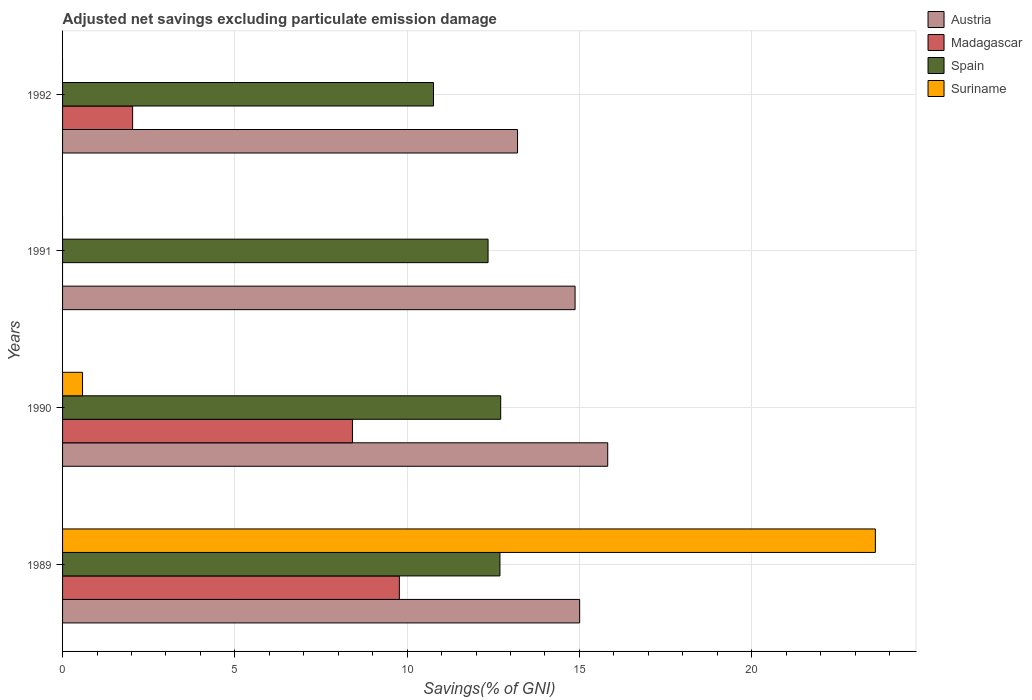How many different coloured bars are there?
Give a very brief answer. 4. How many groups of bars are there?
Provide a short and direct response. 4. Are the number of bars per tick equal to the number of legend labels?
Give a very brief answer. No. What is the label of the 1st group of bars from the top?
Give a very brief answer. 1992. In how many cases, is the number of bars for a given year not equal to the number of legend labels?
Make the answer very short. 2. What is the adjusted net savings in Austria in 1989?
Provide a short and direct response. 15.01. Across all years, what is the maximum adjusted net savings in Austria?
Give a very brief answer. 15.82. Across all years, what is the minimum adjusted net savings in Austria?
Your answer should be very brief. 13.2. What is the total adjusted net savings in Spain in the graph?
Give a very brief answer. 48.52. What is the difference between the adjusted net savings in Spain in 1989 and that in 1991?
Offer a very short reply. 0.34. What is the difference between the adjusted net savings in Suriname in 1990 and the adjusted net savings in Austria in 1992?
Provide a succinct answer. -12.63. What is the average adjusted net savings in Madagascar per year?
Give a very brief answer. 5.06. In the year 1989, what is the difference between the adjusted net savings in Suriname and adjusted net savings in Austria?
Provide a short and direct response. 8.58. In how many years, is the adjusted net savings in Suriname greater than 7 %?
Your response must be concise. 1. What is the ratio of the adjusted net savings in Austria in 1990 to that in 1992?
Provide a short and direct response. 1.2. Is the difference between the adjusted net savings in Suriname in 1989 and 1990 greater than the difference between the adjusted net savings in Austria in 1989 and 1990?
Keep it short and to the point. Yes. What is the difference between the highest and the second highest adjusted net savings in Austria?
Provide a succinct answer. 0.81. What is the difference between the highest and the lowest adjusted net savings in Suriname?
Your answer should be compact. 23.59. In how many years, is the adjusted net savings in Madagascar greater than the average adjusted net savings in Madagascar taken over all years?
Provide a short and direct response. 2. Is it the case that in every year, the sum of the adjusted net savings in Austria and adjusted net savings in Madagascar is greater than the sum of adjusted net savings in Suriname and adjusted net savings in Spain?
Your response must be concise. No. Is it the case that in every year, the sum of the adjusted net savings in Spain and adjusted net savings in Austria is greater than the adjusted net savings in Madagascar?
Your response must be concise. Yes. How many bars are there?
Provide a succinct answer. 13. What is the difference between two consecutive major ticks on the X-axis?
Your response must be concise. 5. Are the values on the major ticks of X-axis written in scientific E-notation?
Provide a short and direct response. No. Does the graph contain any zero values?
Offer a very short reply. Yes. Does the graph contain grids?
Make the answer very short. Yes. How many legend labels are there?
Provide a short and direct response. 4. How are the legend labels stacked?
Keep it short and to the point. Vertical. What is the title of the graph?
Your answer should be compact. Adjusted net savings excluding particulate emission damage. What is the label or title of the X-axis?
Your answer should be very brief. Savings(% of GNI). What is the Savings(% of GNI) of Austria in 1989?
Ensure brevity in your answer.  15.01. What is the Savings(% of GNI) in Madagascar in 1989?
Keep it short and to the point. 9.77. What is the Savings(% of GNI) in Spain in 1989?
Make the answer very short. 12.69. What is the Savings(% of GNI) of Suriname in 1989?
Your response must be concise. 23.59. What is the Savings(% of GNI) of Austria in 1990?
Give a very brief answer. 15.82. What is the Savings(% of GNI) of Madagascar in 1990?
Keep it short and to the point. 8.41. What is the Savings(% of GNI) in Spain in 1990?
Your answer should be very brief. 12.72. What is the Savings(% of GNI) in Suriname in 1990?
Your answer should be compact. 0.58. What is the Savings(% of GNI) in Austria in 1991?
Provide a short and direct response. 14.87. What is the Savings(% of GNI) in Madagascar in 1991?
Your answer should be very brief. 0. What is the Savings(% of GNI) of Spain in 1991?
Offer a very short reply. 12.35. What is the Savings(% of GNI) in Austria in 1992?
Make the answer very short. 13.2. What is the Savings(% of GNI) in Madagascar in 1992?
Your answer should be very brief. 2.03. What is the Savings(% of GNI) in Spain in 1992?
Ensure brevity in your answer.  10.77. What is the Savings(% of GNI) of Suriname in 1992?
Ensure brevity in your answer.  0. Across all years, what is the maximum Savings(% of GNI) of Austria?
Offer a terse response. 15.82. Across all years, what is the maximum Savings(% of GNI) of Madagascar?
Make the answer very short. 9.77. Across all years, what is the maximum Savings(% of GNI) of Spain?
Make the answer very short. 12.72. Across all years, what is the maximum Savings(% of GNI) of Suriname?
Offer a terse response. 23.59. Across all years, what is the minimum Savings(% of GNI) of Austria?
Give a very brief answer. 13.2. Across all years, what is the minimum Savings(% of GNI) of Spain?
Offer a very short reply. 10.77. Across all years, what is the minimum Savings(% of GNI) of Suriname?
Your answer should be very brief. 0. What is the total Savings(% of GNI) of Austria in the graph?
Give a very brief answer. 58.91. What is the total Savings(% of GNI) of Madagascar in the graph?
Keep it short and to the point. 20.22. What is the total Savings(% of GNI) in Spain in the graph?
Provide a short and direct response. 48.52. What is the total Savings(% of GNI) of Suriname in the graph?
Provide a short and direct response. 24.17. What is the difference between the Savings(% of GNI) of Austria in 1989 and that in 1990?
Offer a terse response. -0.81. What is the difference between the Savings(% of GNI) in Madagascar in 1989 and that in 1990?
Make the answer very short. 1.36. What is the difference between the Savings(% of GNI) in Spain in 1989 and that in 1990?
Your response must be concise. -0.02. What is the difference between the Savings(% of GNI) of Suriname in 1989 and that in 1990?
Provide a succinct answer. 23.01. What is the difference between the Savings(% of GNI) of Austria in 1989 and that in 1991?
Keep it short and to the point. 0.13. What is the difference between the Savings(% of GNI) of Spain in 1989 and that in 1991?
Your response must be concise. 0.34. What is the difference between the Savings(% of GNI) in Austria in 1989 and that in 1992?
Ensure brevity in your answer.  1.8. What is the difference between the Savings(% of GNI) of Madagascar in 1989 and that in 1992?
Provide a succinct answer. 7.74. What is the difference between the Savings(% of GNI) in Spain in 1989 and that in 1992?
Make the answer very short. 1.93. What is the difference between the Savings(% of GNI) in Austria in 1990 and that in 1991?
Give a very brief answer. 0.95. What is the difference between the Savings(% of GNI) in Spain in 1990 and that in 1991?
Keep it short and to the point. 0.37. What is the difference between the Savings(% of GNI) in Austria in 1990 and that in 1992?
Provide a short and direct response. 2.62. What is the difference between the Savings(% of GNI) in Madagascar in 1990 and that in 1992?
Make the answer very short. 6.38. What is the difference between the Savings(% of GNI) of Spain in 1990 and that in 1992?
Your response must be concise. 1.95. What is the difference between the Savings(% of GNI) of Austria in 1991 and that in 1992?
Ensure brevity in your answer.  1.67. What is the difference between the Savings(% of GNI) of Spain in 1991 and that in 1992?
Ensure brevity in your answer.  1.58. What is the difference between the Savings(% of GNI) of Austria in 1989 and the Savings(% of GNI) of Madagascar in 1990?
Ensure brevity in your answer.  6.59. What is the difference between the Savings(% of GNI) in Austria in 1989 and the Savings(% of GNI) in Spain in 1990?
Offer a very short reply. 2.29. What is the difference between the Savings(% of GNI) in Austria in 1989 and the Savings(% of GNI) in Suriname in 1990?
Your response must be concise. 14.43. What is the difference between the Savings(% of GNI) of Madagascar in 1989 and the Savings(% of GNI) of Spain in 1990?
Offer a very short reply. -2.94. What is the difference between the Savings(% of GNI) of Madagascar in 1989 and the Savings(% of GNI) of Suriname in 1990?
Keep it short and to the point. 9.19. What is the difference between the Savings(% of GNI) of Spain in 1989 and the Savings(% of GNI) of Suriname in 1990?
Ensure brevity in your answer.  12.11. What is the difference between the Savings(% of GNI) in Austria in 1989 and the Savings(% of GNI) in Spain in 1991?
Your answer should be compact. 2.66. What is the difference between the Savings(% of GNI) of Madagascar in 1989 and the Savings(% of GNI) of Spain in 1991?
Give a very brief answer. -2.57. What is the difference between the Savings(% of GNI) in Austria in 1989 and the Savings(% of GNI) in Madagascar in 1992?
Offer a terse response. 12.97. What is the difference between the Savings(% of GNI) of Austria in 1989 and the Savings(% of GNI) of Spain in 1992?
Your answer should be very brief. 4.24. What is the difference between the Savings(% of GNI) in Madagascar in 1989 and the Savings(% of GNI) in Spain in 1992?
Your answer should be compact. -0.99. What is the difference between the Savings(% of GNI) of Austria in 1990 and the Savings(% of GNI) of Spain in 1991?
Offer a terse response. 3.47. What is the difference between the Savings(% of GNI) of Madagascar in 1990 and the Savings(% of GNI) of Spain in 1991?
Make the answer very short. -3.94. What is the difference between the Savings(% of GNI) of Austria in 1990 and the Savings(% of GNI) of Madagascar in 1992?
Provide a short and direct response. 13.79. What is the difference between the Savings(% of GNI) in Austria in 1990 and the Savings(% of GNI) in Spain in 1992?
Provide a succinct answer. 5.06. What is the difference between the Savings(% of GNI) of Madagascar in 1990 and the Savings(% of GNI) of Spain in 1992?
Offer a terse response. -2.35. What is the difference between the Savings(% of GNI) of Austria in 1991 and the Savings(% of GNI) of Madagascar in 1992?
Your response must be concise. 12.84. What is the difference between the Savings(% of GNI) of Austria in 1991 and the Savings(% of GNI) of Spain in 1992?
Your answer should be very brief. 4.11. What is the average Savings(% of GNI) of Austria per year?
Provide a succinct answer. 14.73. What is the average Savings(% of GNI) in Madagascar per year?
Offer a terse response. 5.06. What is the average Savings(% of GNI) of Spain per year?
Offer a very short reply. 12.13. What is the average Savings(% of GNI) in Suriname per year?
Offer a terse response. 6.04. In the year 1989, what is the difference between the Savings(% of GNI) in Austria and Savings(% of GNI) in Madagascar?
Keep it short and to the point. 5.23. In the year 1989, what is the difference between the Savings(% of GNI) of Austria and Savings(% of GNI) of Spain?
Your answer should be compact. 2.31. In the year 1989, what is the difference between the Savings(% of GNI) in Austria and Savings(% of GNI) in Suriname?
Offer a terse response. -8.58. In the year 1989, what is the difference between the Savings(% of GNI) in Madagascar and Savings(% of GNI) in Spain?
Offer a very short reply. -2.92. In the year 1989, what is the difference between the Savings(% of GNI) of Madagascar and Savings(% of GNI) of Suriname?
Provide a succinct answer. -13.82. In the year 1989, what is the difference between the Savings(% of GNI) of Spain and Savings(% of GNI) of Suriname?
Make the answer very short. -10.9. In the year 1990, what is the difference between the Savings(% of GNI) in Austria and Savings(% of GNI) in Madagascar?
Offer a terse response. 7.41. In the year 1990, what is the difference between the Savings(% of GNI) in Austria and Savings(% of GNI) in Spain?
Your response must be concise. 3.11. In the year 1990, what is the difference between the Savings(% of GNI) of Austria and Savings(% of GNI) of Suriname?
Your answer should be compact. 15.24. In the year 1990, what is the difference between the Savings(% of GNI) of Madagascar and Savings(% of GNI) of Spain?
Give a very brief answer. -4.3. In the year 1990, what is the difference between the Savings(% of GNI) of Madagascar and Savings(% of GNI) of Suriname?
Your response must be concise. 7.83. In the year 1990, what is the difference between the Savings(% of GNI) of Spain and Savings(% of GNI) of Suriname?
Provide a short and direct response. 12.14. In the year 1991, what is the difference between the Savings(% of GNI) of Austria and Savings(% of GNI) of Spain?
Provide a succinct answer. 2.53. In the year 1992, what is the difference between the Savings(% of GNI) in Austria and Savings(% of GNI) in Madagascar?
Offer a terse response. 11.17. In the year 1992, what is the difference between the Savings(% of GNI) of Austria and Savings(% of GNI) of Spain?
Make the answer very short. 2.44. In the year 1992, what is the difference between the Savings(% of GNI) in Madagascar and Savings(% of GNI) in Spain?
Keep it short and to the point. -8.73. What is the ratio of the Savings(% of GNI) in Austria in 1989 to that in 1990?
Your answer should be very brief. 0.95. What is the ratio of the Savings(% of GNI) of Madagascar in 1989 to that in 1990?
Give a very brief answer. 1.16. What is the ratio of the Savings(% of GNI) of Suriname in 1989 to that in 1990?
Offer a very short reply. 40.71. What is the ratio of the Savings(% of GNI) of Austria in 1989 to that in 1991?
Offer a very short reply. 1.01. What is the ratio of the Savings(% of GNI) in Spain in 1989 to that in 1991?
Offer a terse response. 1.03. What is the ratio of the Savings(% of GNI) of Austria in 1989 to that in 1992?
Offer a very short reply. 1.14. What is the ratio of the Savings(% of GNI) in Madagascar in 1989 to that in 1992?
Your answer should be very brief. 4.81. What is the ratio of the Savings(% of GNI) in Spain in 1989 to that in 1992?
Give a very brief answer. 1.18. What is the ratio of the Savings(% of GNI) in Austria in 1990 to that in 1991?
Ensure brevity in your answer.  1.06. What is the ratio of the Savings(% of GNI) of Spain in 1990 to that in 1991?
Provide a succinct answer. 1.03. What is the ratio of the Savings(% of GNI) of Austria in 1990 to that in 1992?
Provide a short and direct response. 1.2. What is the ratio of the Savings(% of GNI) in Madagascar in 1990 to that in 1992?
Offer a terse response. 4.14. What is the ratio of the Savings(% of GNI) in Spain in 1990 to that in 1992?
Give a very brief answer. 1.18. What is the ratio of the Savings(% of GNI) of Austria in 1991 to that in 1992?
Offer a terse response. 1.13. What is the ratio of the Savings(% of GNI) of Spain in 1991 to that in 1992?
Make the answer very short. 1.15. What is the difference between the highest and the second highest Savings(% of GNI) of Austria?
Offer a terse response. 0.81. What is the difference between the highest and the second highest Savings(% of GNI) of Madagascar?
Offer a terse response. 1.36. What is the difference between the highest and the second highest Savings(% of GNI) of Spain?
Provide a short and direct response. 0.02. What is the difference between the highest and the lowest Savings(% of GNI) of Austria?
Your response must be concise. 2.62. What is the difference between the highest and the lowest Savings(% of GNI) in Madagascar?
Provide a short and direct response. 9.77. What is the difference between the highest and the lowest Savings(% of GNI) of Spain?
Your answer should be very brief. 1.95. What is the difference between the highest and the lowest Savings(% of GNI) in Suriname?
Your response must be concise. 23.59. 